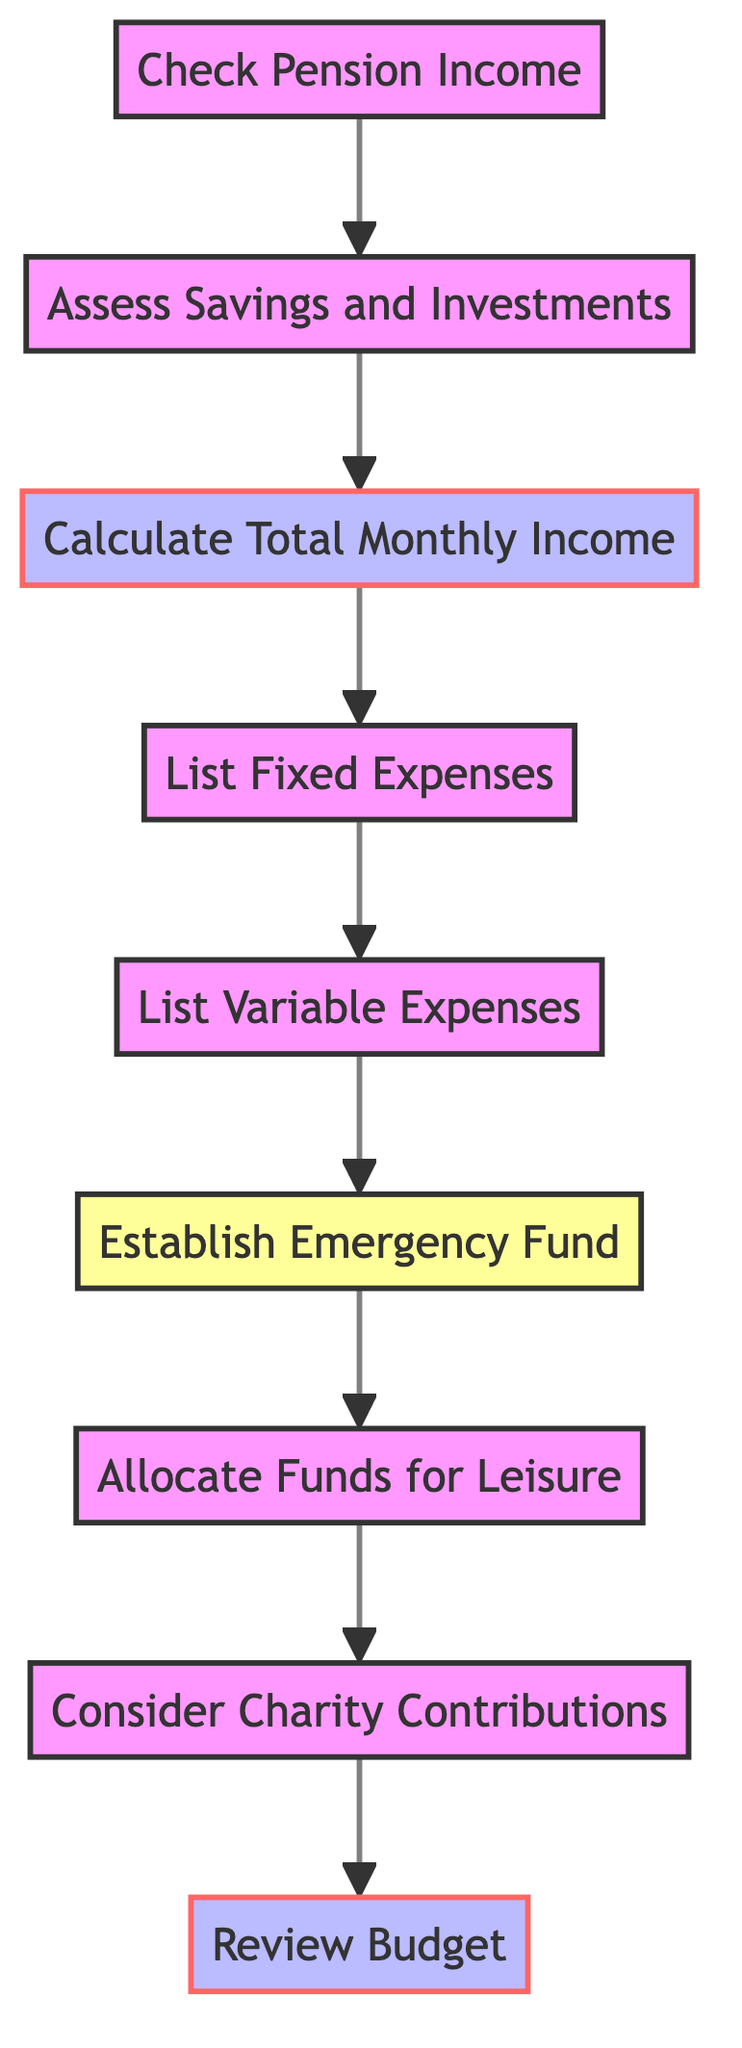What is the first step in the budget planning process? The first step listed in the diagram is "Check Pension Income." This is shown at the beginning of the flowchart and indicates the starting point for the budget planning process.
Answer: Check Pension Income How many total steps are included in the diagram? The diagram comprises a total of 9 steps. Each step represents a specific action or decision in the budget planning process.
Answer: 9 What step follows "Calculate Total Monthly Income"? The step that follows "Calculate Total Monthly Income" is "List Fixed Expenses." This is evident from the flow direction from one step to the next in the diagram.
Answer: List Fixed Expenses Which step emphasizes preparing for unexpected situations? The step that emphasizes preparing for unexpected situations is "Establish Emergency Fund." This step specifically mentions allocating funds for emergencies, especially related to typhoons.
Answer: Establish Emergency Fund What is the last step in the budget planning process? The last step in the budget planning process as shown in the diagram is "Review Budget." This indicates that after all other steps, there is a need to review and adjust the budget as necessary.
Answer: Review Budget Which two steps are classified as decision points? The steps classified as decision points are "Establish Emergency Fund" and "Review Budget." These steps require a level of decision-making regarding financial allocations and budget adjustments.
Answer: Establish Emergency Fund, Review Budget How many fixed expense types are mentioned in the diagram? The diagram refers to "List Fixed Expenses," which typically encompasses all fixed costs like utilities, rent, and insurance together, although it does not specify an exact number of types.
Answer: Not specified What is the relationship between "Assess Savings and Investments" and "Calculate Total Monthly Income"? The relationship is sequential; "Assess Savings and Investments" leads directly to "Calculate Total Monthly Income," indicating that understanding savings and investments is foundational to calculating total income.
Answer: Sequential relationship What type of expenses are included in the "List Variable Expenses"? The "List Variable Expenses" step includes expenses like groceries, healthcare, and transportation. Specifically, it also indicates the consideration of emergency costs related to typhoon preparedness.
Answer: Groceries, healthcare, transportation, emergency costs 